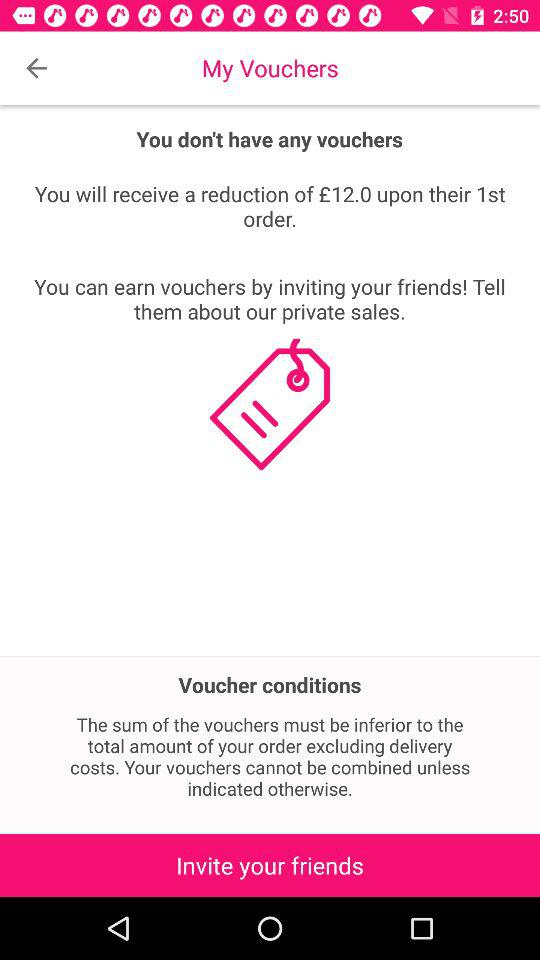How many vouchers do I have?
Answer the question using a single word or phrase. 0 